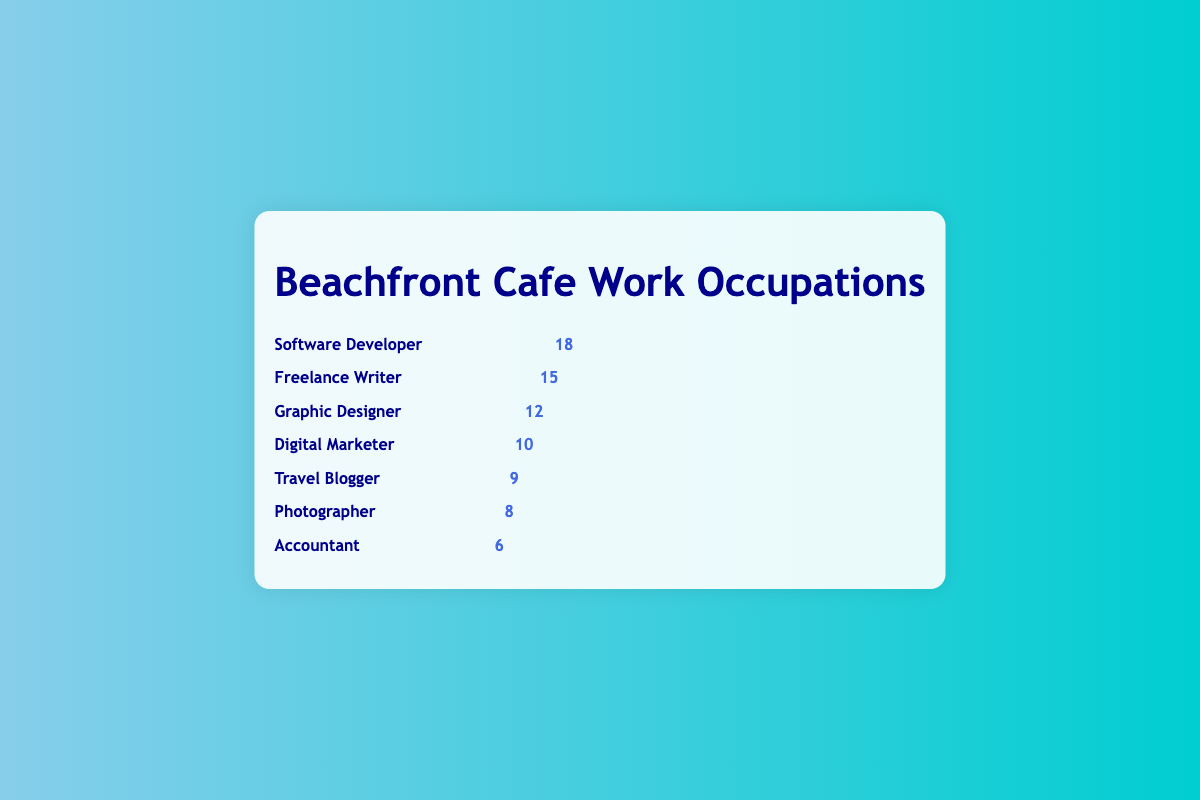Which profession has the highest number of customers at the cafe? From the figure, we can see that the occupation row with the most icons is for Software Developers. By counting the icons, it is evident that Software Developers are the highest, with a count of 18.
Answer: Software Developer Which profession has fewer customers than Freelance Writers but more than Travel Bloggers? Freelance Writers have 15 customers, and Travel Bloggers have 9. Looking for a profession with a count between these numbers, we find that Graphic Designers have 12 customers, which fits the criteria.
Answer: Graphic Designer How many customers at the cafe are either Digital Marketers or Photographers? From the figure, Digital Marketers have 10 and Photographers have 8. Adding these together: 10 + 8 = 18.
Answer: 18 What is the total number of icons representing all the listed professions? Adding the counts for each profession: 18 (Software Developers) + 15 (Freelance Writers) + 12 (Graphic Designers) + 10 (Digital Marketers) + 9 (Travel Bloggers) + 8 (Photographers) + 6 (Accountants) = 78.
Answer: 78 How many more Freelance Writers are there than Accountants? Freelance Writers have 15 customers, and Accountants have 6. The difference is 15 - 6 = 9.
Answer: 9 Which profession has the second fewest customers? The counts are 18, 15, 12, 10, 9, 8, and 6. The lowest is 6 (Accountants), followed by 8 (Photographers).
Answer: Photographer Which profession(s) have a customer count in the single digits? The counts 10 (Digital Marketers), 9 (Travel Bloggers), 8 (Photographers), 6 (Accountants). Here, 9, 8, and 6 are single-digit values. Thus, Travel Bloggers, Photographers, and Accountants qualify.
Answer: Travel Blogger, Photographer, Accountant 